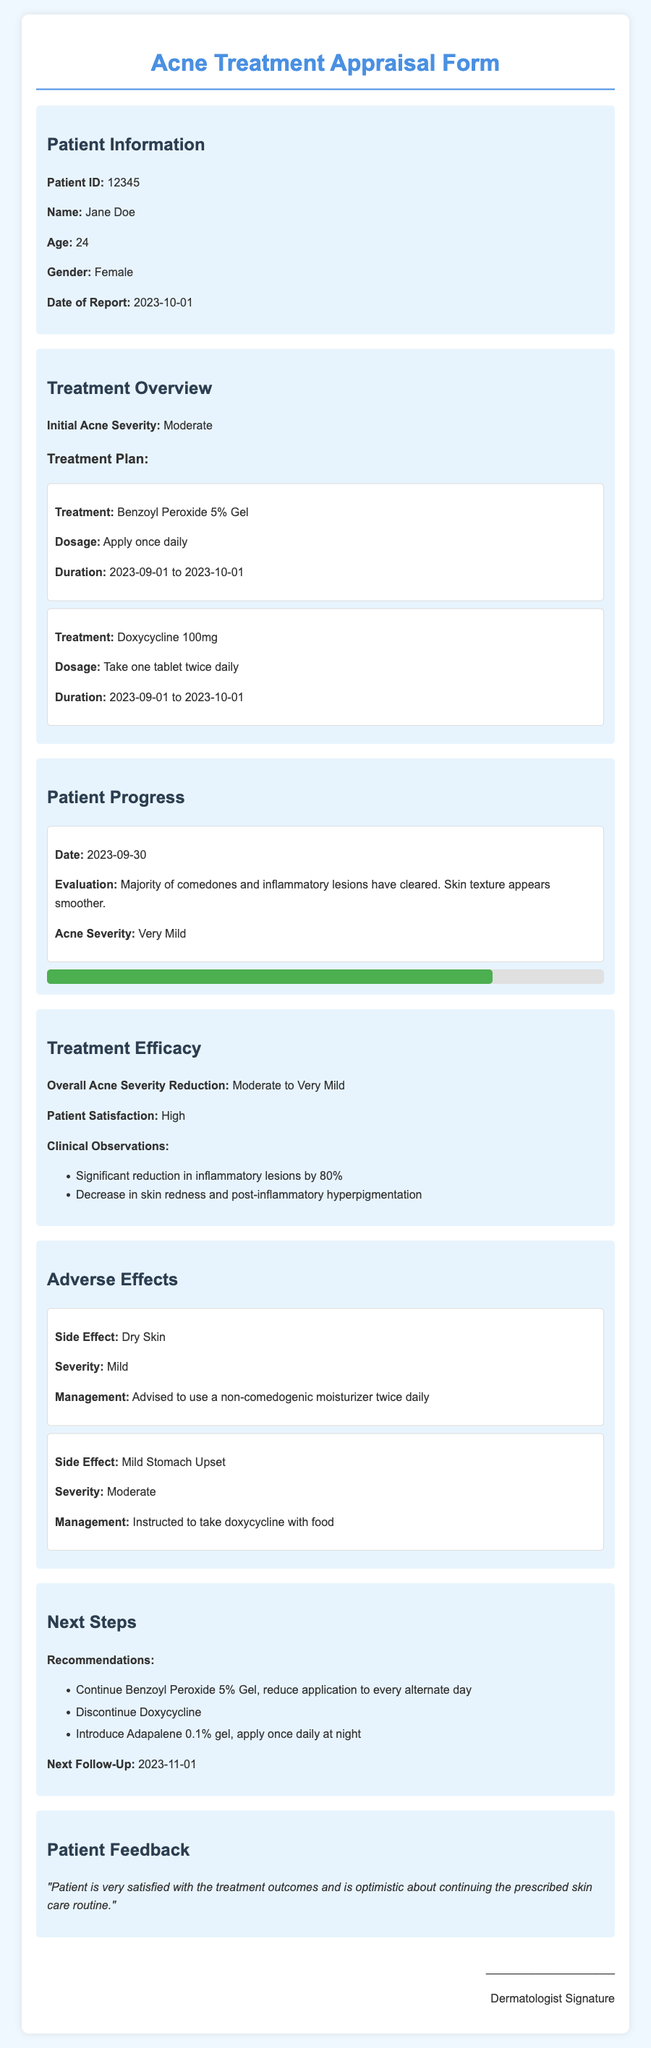What is the Patient ID? The Patient ID is listed under Patient Information in the document, which identifies the patient for the report.
Answer: 12345 What is the initial acne severity? The initial acne severity is specified in the Treatment Overview section, indicating the severity level before treatment.
Answer: Moderate What treatment was prescribed for acne? The document lists the treatment plans under Treatment Overview, detailing the medications given to the patient.
Answer: Benzoyl Peroxide 5% Gel What is the patient's age? The patient's age is provided in the Patient Information section, which helps to contextualize the treatment outcomes.
Answer: 24 What was the overall acne severity reduction? The Treatment Efficacy section summarizes the changes in acne severity after treatment, highlighting progress.
Answer: Moderate to Very Mild When is the next follow-up scheduled? The date for the next follow-up is mentioned in the Next Steps section, which indicates future care planning.
Answer: 2023-11-01 What side effect was managed with a moisturizer? The Adverse Effects section lists side effects experienced by the patient along with their management strategies.
Answer: Dry Skin What is the patient's feedback on the treatment? The Patient Feedback section captures the patient's sentiment regarding their treatment journey and satisfaction levels.
Answer: "Patient is very satisfied with the treatment outcomes and is optimistic about continuing the prescribed skin care routine." How many inflammatory lesions were reduced? This value is provided in the Clinical Observations section under Treatment Efficacy, summarizing the treatment results quantitatively.
Answer: 80% 